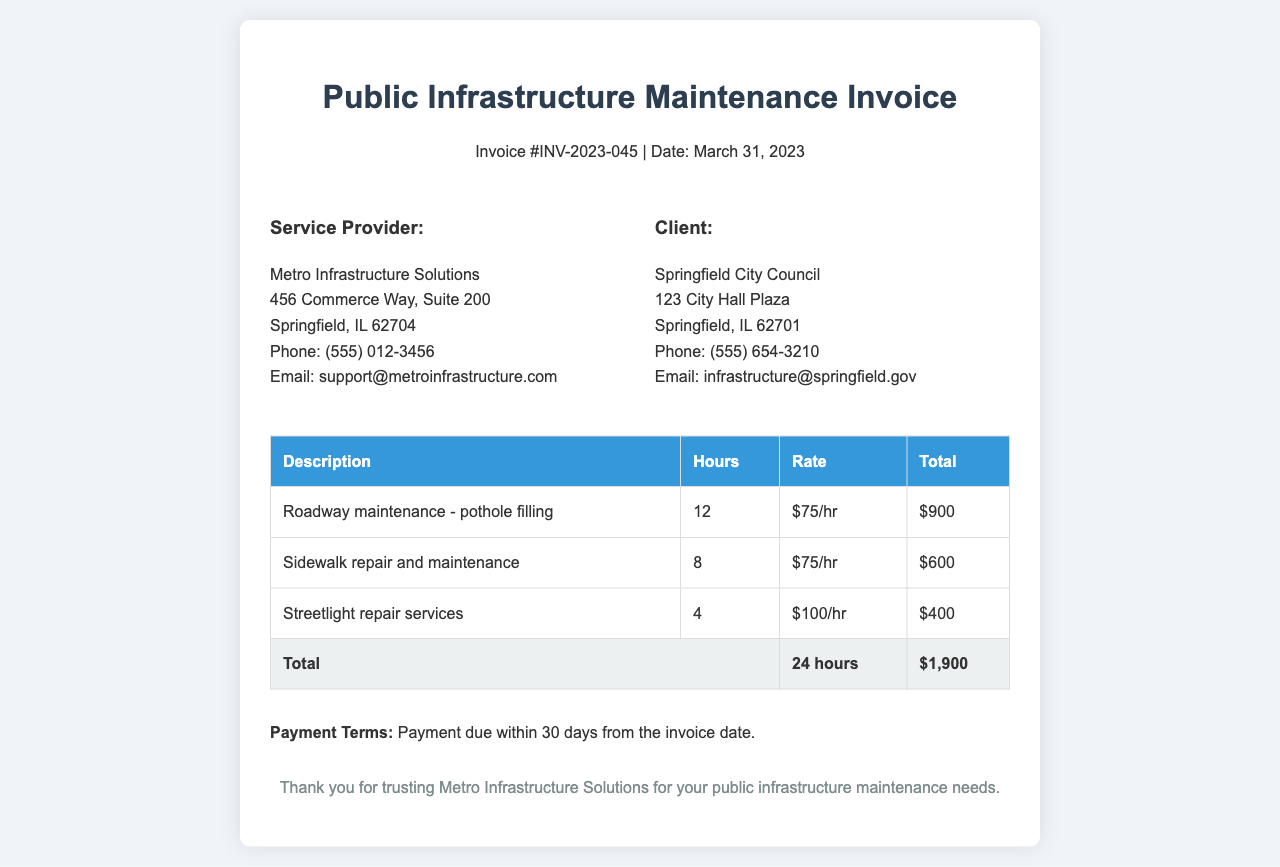What is the invoice number? The invoice number is specified in the document, which is #INV-2023-045.
Answer: #INV-2023-045 Who is the service provider? The service provider's name is mentioned in the document as Metro Infrastructure Solutions.
Answer: Metro Infrastructure Solutions How many hours were worked in total? The total hours can be calculated from the individual service entries, which sum up to 24 hours.
Answer: 24 hours What is the charge for roadway maintenance? The charge for roadway maintenance is specified as $900 for pothole filling.
Answer: $900 What is the email of the client? The client's email address is provided in the document, which is infrastructure@springfield.gov.
Answer: infrastructure@springfield.gov How much was charged for streetlight repair services? The total charge listed for streetlight repair services is $400.
Answer: $400 What is the payment term? The payment term is also specified in the document, indicating payment is due within 30 days from the invoice date.
Answer: 30 days How much do they charge per hour for sidewalk repair? The hourly rate for sidewalk repair and maintenance is indicated as $75/hr in the document.
Answer: $75/hr What is the total invoice amount? The total amount for the services rendered is provided at the end, which is $1,900.
Answer: $1,900 